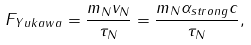<formula> <loc_0><loc_0><loc_500><loc_500>F _ { Y u k a w a } = \frac { m _ { N } v _ { N } } { \tau _ { N } } = \frac { m _ { N } \alpha _ { s t r o n g } c } { \tau _ { N } } ,</formula> 